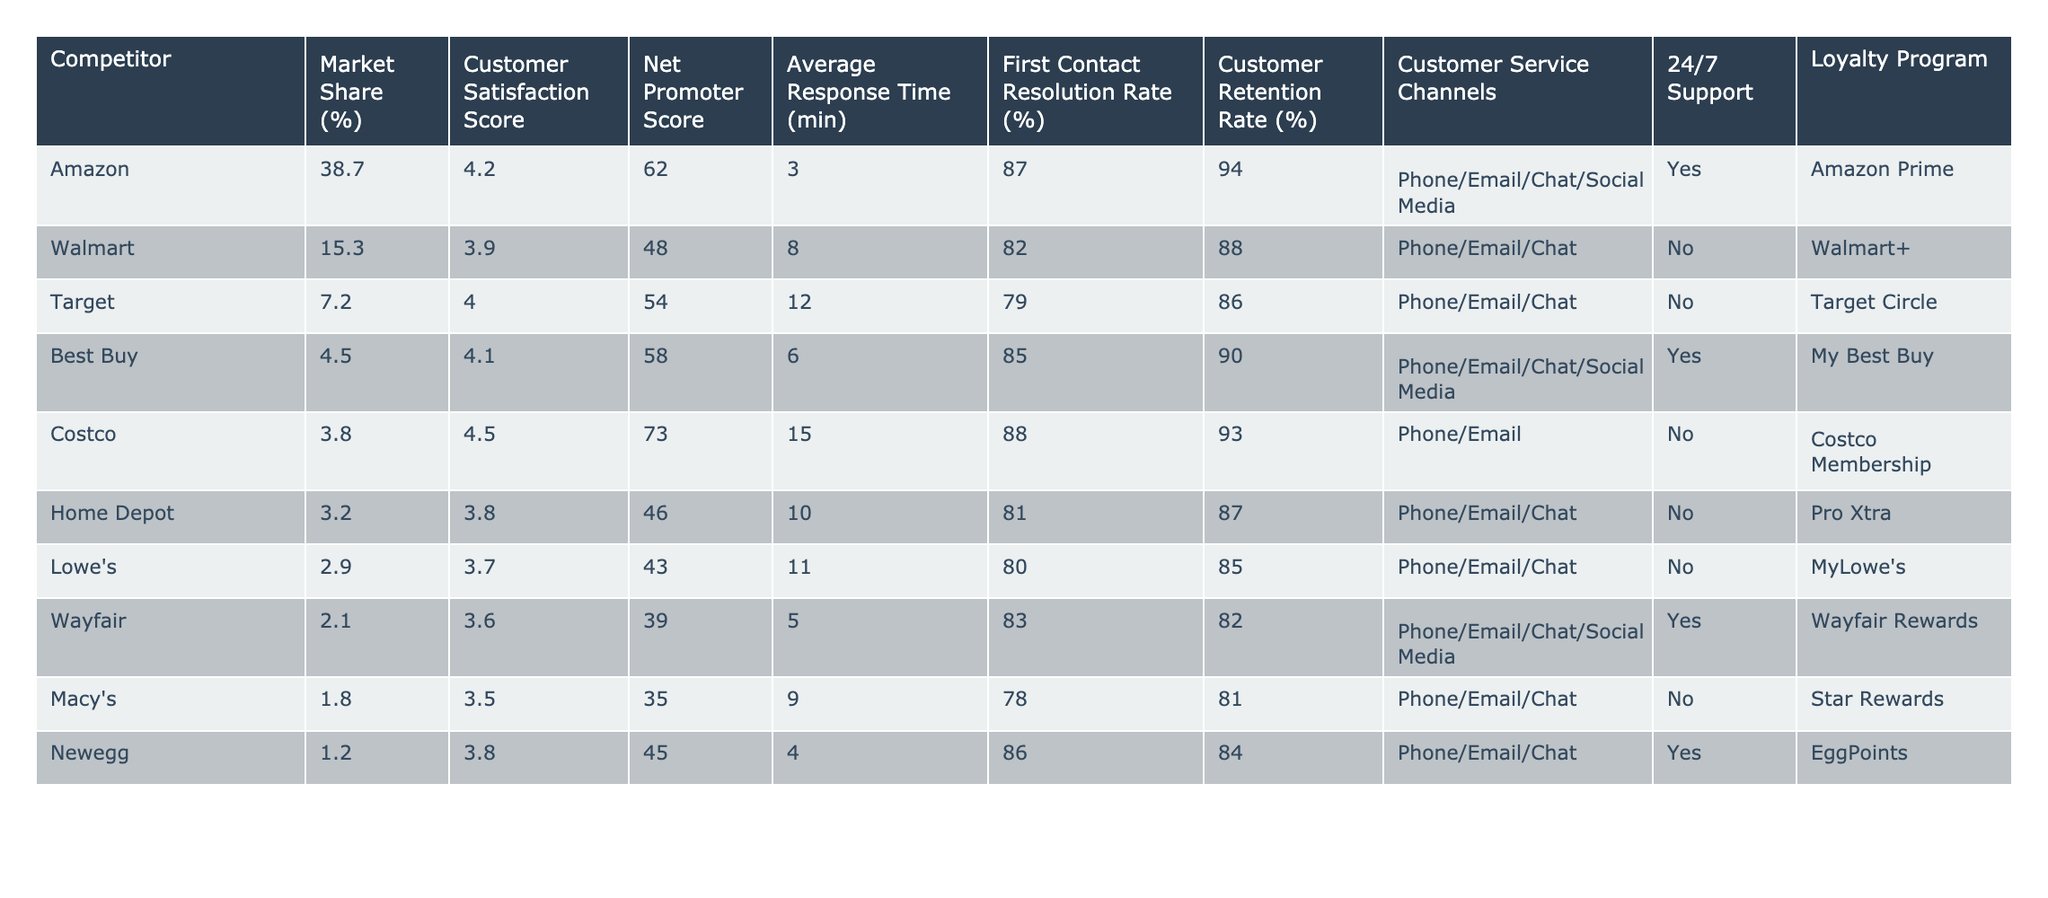What's the market share percentage of Amazon? The table lists Amazon with a market share of 38.7%, which is directly visible in the corresponding row under the "Market Share (%)" column.
Answer: 38.7% Which competitor has the highest customer satisfaction score? By examining the "Customer Satisfaction Score" column, Costco has the highest score of 4.5 among all competitors listed.
Answer: Costco What is the average response time across all competitors? Adding the response times (3 + 8 + 12 + 6 + 15 + 10 + 11 + 5 + 9 + 4 = 89) gives a total of 89 minutes. With 10 competitors, the average is 89 / 10 = 8.9 minutes.
Answer: 8.9 minutes Do any competitors offer 24/7 customer support? I can see from the "24/7 Support" column that only Amazon, Best Buy, and Wayfair provide 24/7 support, which means the answer is yes.
Answer: Yes Which competitor has the lowest Net Promoter Score? Looking at the "Net Promoter Score" column, Macy's has the lowest score of 35, making it the competitor with the lowest NPS.
Answer: Macy's What is the difference in the Customer Retention Rate between Amazon and Walmart? Amazon has a Customer Retention Rate of 94%, while Walmart has 88%. The difference is 94 - 88 = 6%.
Answer: 6% Does Target have a loyalty program? Checking the "Loyalty Program" column, Target Circle is listed under Target, indicating that they do have a loyalty program.
Answer: Yes Which company has a higher First Contact Resolution Rate, Best Buy or Costco? Best Buy has a rate of 85%, while Costco has 88%. Since 88% is greater than 85%, Costco has a higher rate.
Answer: Costco If we rank customer satisfaction scores, what position does Walmart hold? Walmart's score is 3.9, and when ranked among the competitors, it places 6th out of 10 based on the scores provided.
Answer: 6th What competitor has the highest market share among those with 24/7 support? The competitors that offer 24/7 support are Amazon (38.7%) and Best Buy (4.5%). Among these, Amazon has the highest market share at 38.7%.
Answer: Amazon 